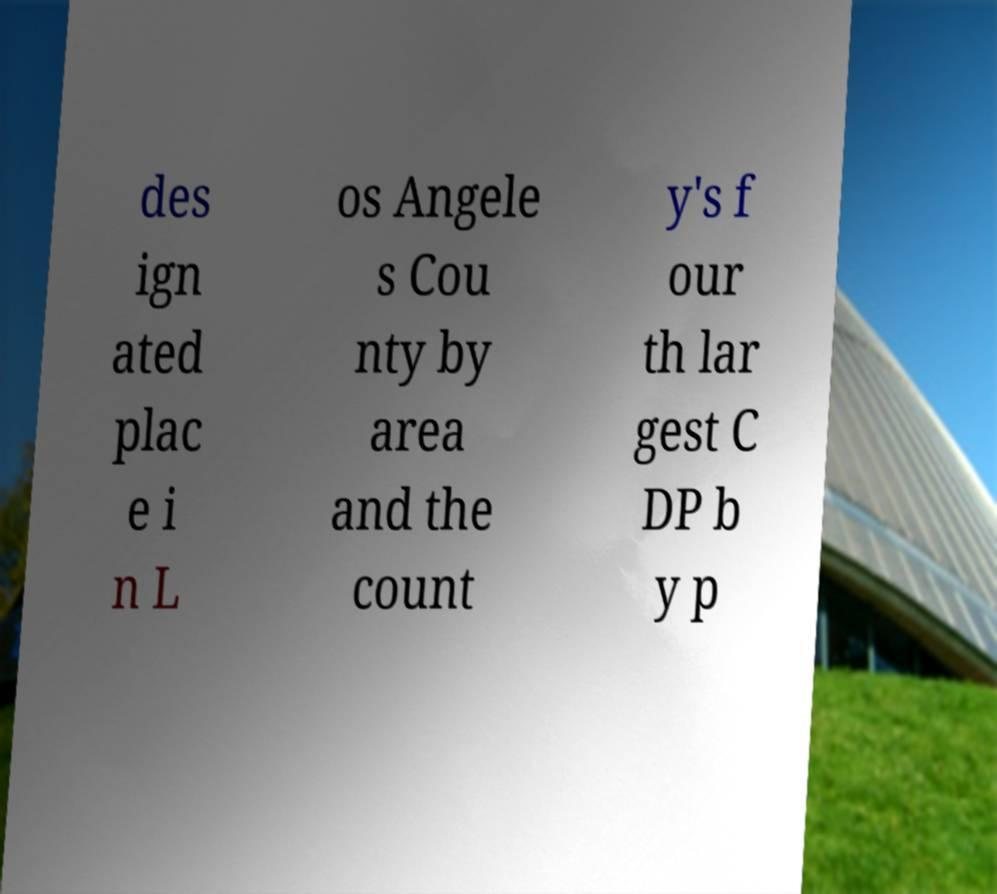Could you assist in decoding the text presented in this image and type it out clearly? des ign ated plac e i n L os Angele s Cou nty by area and the count y's f our th lar gest C DP b y p 